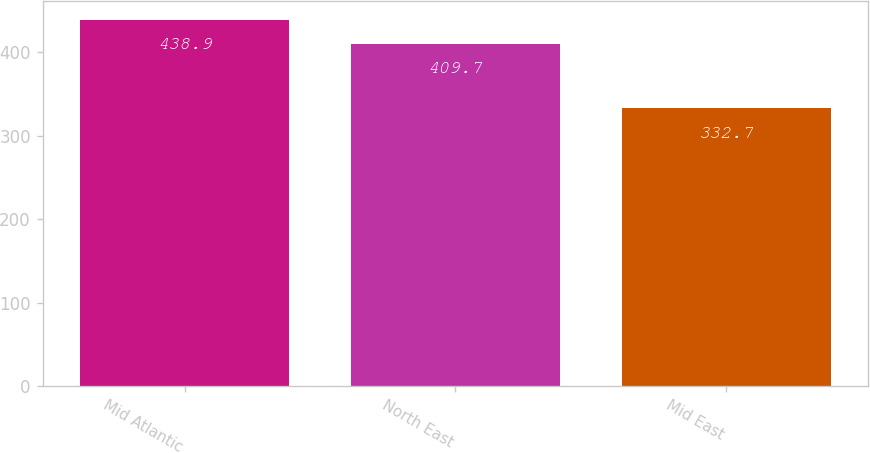Convert chart. <chart><loc_0><loc_0><loc_500><loc_500><bar_chart><fcel>Mid Atlantic<fcel>North East<fcel>Mid East<nl><fcel>438.9<fcel>409.7<fcel>332.7<nl></chart> 